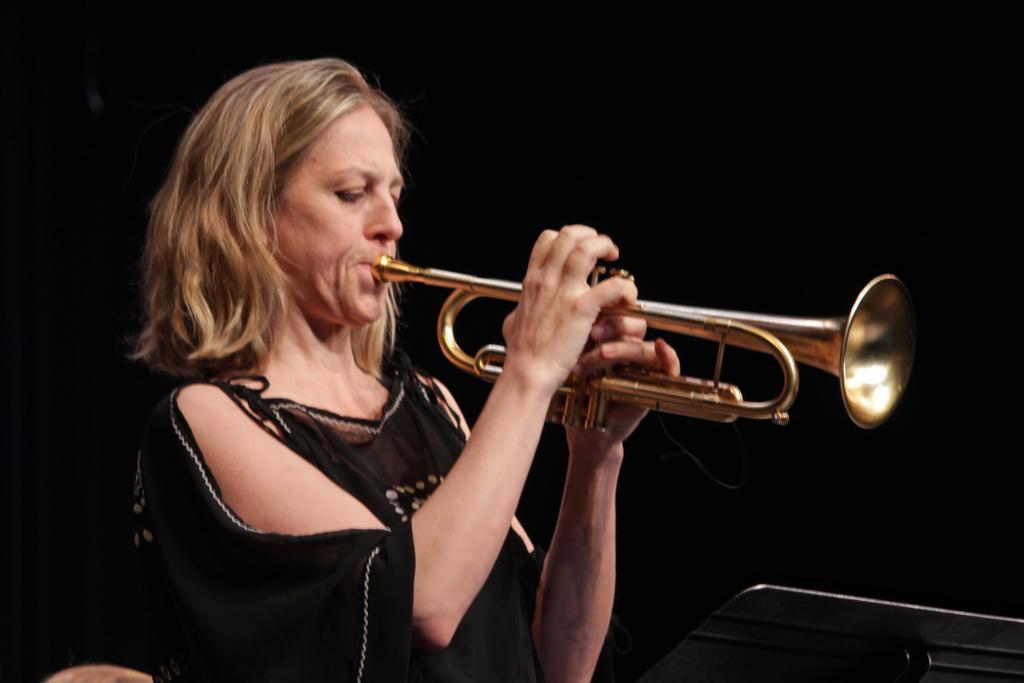Who is the main subject in the image? There is a woman in the image. What is the woman doing in the image? The woman is playing a musical instrument. Can you describe any additional elements in the image? There is a pad in the bottom right corner of the image. What is the color of the background in the image? The background of the image is dark. What type of pain is the woman experiencing while playing the musical instrument in the image? There is no indication in the image that the woman is experiencing any pain while playing the musical instrument. 